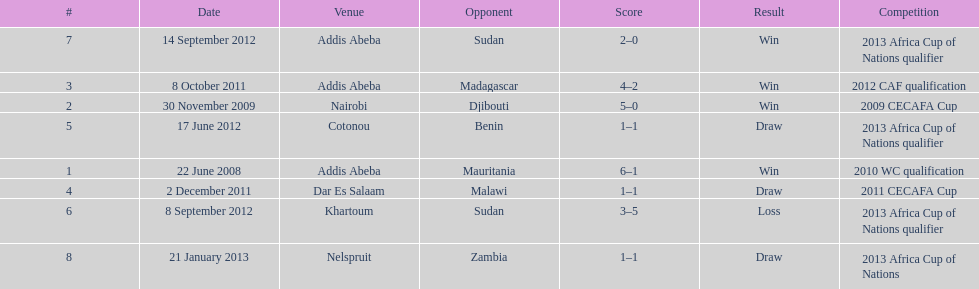For each winning game, what was their score? 6-1, 5-0, 4-2, 2-0. 